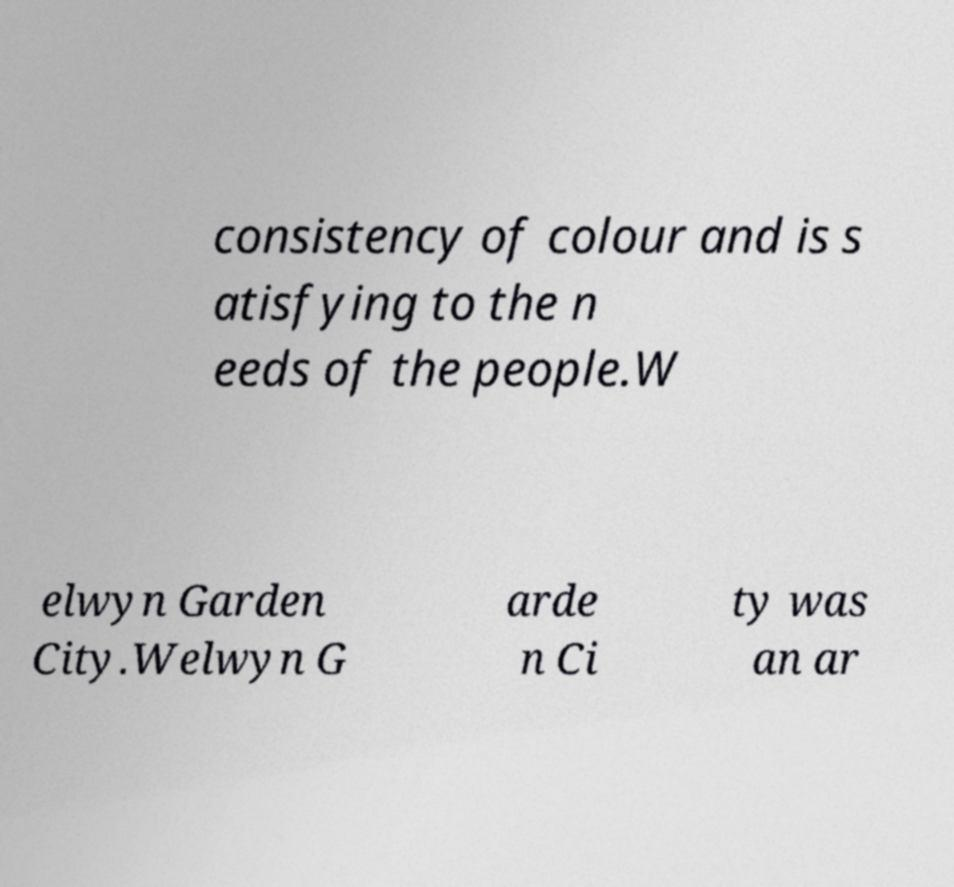I need the written content from this picture converted into text. Can you do that? consistency of colour and is s atisfying to the n eeds of the people.W elwyn Garden City.Welwyn G arde n Ci ty was an ar 